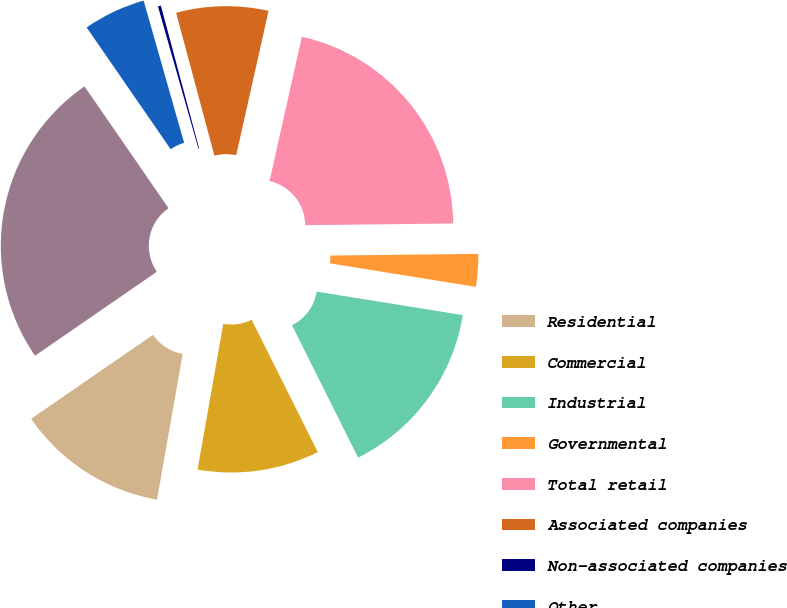Convert chart. <chart><loc_0><loc_0><loc_500><loc_500><pie_chart><fcel>Residential<fcel>Commercial<fcel>Industrial<fcel>Governmental<fcel>Total retail<fcel>Associated companies<fcel>Non-associated companies<fcel>Other<fcel>Total<nl><fcel>12.62%<fcel>10.15%<fcel>15.09%<fcel>2.72%<fcel>21.31%<fcel>7.67%<fcel>0.25%<fcel>5.2%<fcel>24.99%<nl></chart> 